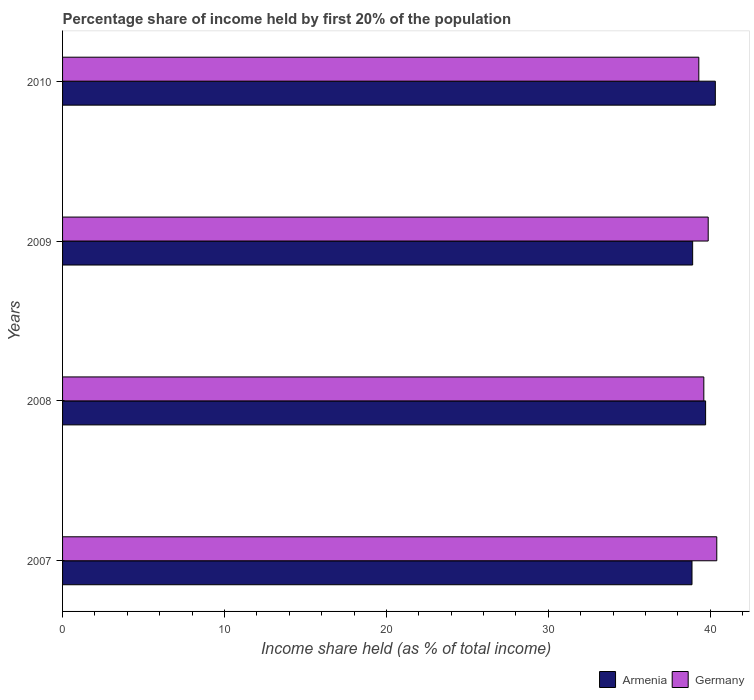How many different coloured bars are there?
Provide a short and direct response. 2. Are the number of bars per tick equal to the number of legend labels?
Ensure brevity in your answer.  Yes. How many bars are there on the 1st tick from the bottom?
Make the answer very short. 2. What is the label of the 3rd group of bars from the top?
Your response must be concise. 2008. In how many cases, is the number of bars for a given year not equal to the number of legend labels?
Make the answer very short. 0. What is the share of income held by first 20% of the population in Armenia in 2007?
Your response must be concise. 38.87. Across all years, what is the maximum share of income held by first 20% of the population in Armenia?
Offer a terse response. 40.31. Across all years, what is the minimum share of income held by first 20% of the population in Germany?
Give a very brief answer. 39.29. In which year was the share of income held by first 20% of the population in Armenia maximum?
Make the answer very short. 2010. In which year was the share of income held by first 20% of the population in Armenia minimum?
Make the answer very short. 2007. What is the total share of income held by first 20% of the population in Germany in the graph?
Keep it short and to the point. 159.16. What is the difference between the share of income held by first 20% of the population in Armenia in 2007 and that in 2008?
Make the answer very short. -0.84. What is the difference between the share of income held by first 20% of the population in Germany in 2010 and the share of income held by first 20% of the population in Armenia in 2007?
Offer a very short reply. 0.42. What is the average share of income held by first 20% of the population in Armenia per year?
Your response must be concise. 39.45. In the year 2008, what is the difference between the share of income held by first 20% of the population in Germany and share of income held by first 20% of the population in Armenia?
Provide a short and direct response. -0.11. In how many years, is the share of income held by first 20% of the population in Germany greater than 8 %?
Ensure brevity in your answer.  4. What is the ratio of the share of income held by first 20% of the population in Germany in 2007 to that in 2009?
Keep it short and to the point. 1.01. Is the share of income held by first 20% of the population in Armenia in 2009 less than that in 2010?
Offer a very short reply. Yes. Is the difference between the share of income held by first 20% of the population in Germany in 2007 and 2008 greater than the difference between the share of income held by first 20% of the population in Armenia in 2007 and 2008?
Give a very brief answer. Yes. What is the difference between the highest and the second highest share of income held by first 20% of the population in Armenia?
Make the answer very short. 0.6. What is the difference between the highest and the lowest share of income held by first 20% of the population in Germany?
Ensure brevity in your answer.  1.11. What does the 2nd bar from the top in 2007 represents?
Your answer should be compact. Armenia. What does the 1st bar from the bottom in 2010 represents?
Provide a short and direct response. Armenia. How many bars are there?
Keep it short and to the point. 8. How many years are there in the graph?
Your answer should be compact. 4. Does the graph contain any zero values?
Give a very brief answer. No. Does the graph contain grids?
Give a very brief answer. No. How are the legend labels stacked?
Provide a succinct answer. Horizontal. What is the title of the graph?
Your answer should be compact. Percentage share of income held by first 20% of the population. What is the label or title of the X-axis?
Your answer should be very brief. Income share held (as % of total income). What is the label or title of the Y-axis?
Your answer should be very brief. Years. What is the Income share held (as % of total income) of Armenia in 2007?
Provide a short and direct response. 38.87. What is the Income share held (as % of total income) in Germany in 2007?
Your answer should be compact. 40.4. What is the Income share held (as % of total income) of Armenia in 2008?
Your response must be concise. 39.71. What is the Income share held (as % of total income) of Germany in 2008?
Your response must be concise. 39.6. What is the Income share held (as % of total income) of Armenia in 2009?
Your answer should be very brief. 38.91. What is the Income share held (as % of total income) of Germany in 2009?
Your response must be concise. 39.87. What is the Income share held (as % of total income) of Armenia in 2010?
Offer a very short reply. 40.31. What is the Income share held (as % of total income) in Germany in 2010?
Offer a very short reply. 39.29. Across all years, what is the maximum Income share held (as % of total income) in Armenia?
Your response must be concise. 40.31. Across all years, what is the maximum Income share held (as % of total income) of Germany?
Offer a terse response. 40.4. Across all years, what is the minimum Income share held (as % of total income) in Armenia?
Your response must be concise. 38.87. Across all years, what is the minimum Income share held (as % of total income) of Germany?
Your answer should be very brief. 39.29. What is the total Income share held (as % of total income) of Armenia in the graph?
Your response must be concise. 157.8. What is the total Income share held (as % of total income) in Germany in the graph?
Provide a short and direct response. 159.16. What is the difference between the Income share held (as % of total income) of Armenia in 2007 and that in 2008?
Your answer should be compact. -0.84. What is the difference between the Income share held (as % of total income) in Germany in 2007 and that in 2008?
Offer a very short reply. 0.8. What is the difference between the Income share held (as % of total income) of Armenia in 2007 and that in 2009?
Your answer should be compact. -0.04. What is the difference between the Income share held (as % of total income) of Germany in 2007 and that in 2009?
Give a very brief answer. 0.53. What is the difference between the Income share held (as % of total income) in Armenia in 2007 and that in 2010?
Keep it short and to the point. -1.44. What is the difference between the Income share held (as % of total income) in Germany in 2007 and that in 2010?
Ensure brevity in your answer.  1.11. What is the difference between the Income share held (as % of total income) of Germany in 2008 and that in 2009?
Provide a short and direct response. -0.27. What is the difference between the Income share held (as % of total income) in Germany in 2008 and that in 2010?
Provide a succinct answer. 0.31. What is the difference between the Income share held (as % of total income) in Armenia in 2009 and that in 2010?
Provide a succinct answer. -1.4. What is the difference between the Income share held (as % of total income) in Germany in 2009 and that in 2010?
Your answer should be very brief. 0.58. What is the difference between the Income share held (as % of total income) of Armenia in 2007 and the Income share held (as % of total income) of Germany in 2008?
Your answer should be compact. -0.73. What is the difference between the Income share held (as % of total income) of Armenia in 2007 and the Income share held (as % of total income) of Germany in 2009?
Your answer should be compact. -1. What is the difference between the Income share held (as % of total income) in Armenia in 2007 and the Income share held (as % of total income) in Germany in 2010?
Provide a short and direct response. -0.42. What is the difference between the Income share held (as % of total income) of Armenia in 2008 and the Income share held (as % of total income) of Germany in 2009?
Keep it short and to the point. -0.16. What is the difference between the Income share held (as % of total income) in Armenia in 2008 and the Income share held (as % of total income) in Germany in 2010?
Keep it short and to the point. 0.42. What is the difference between the Income share held (as % of total income) of Armenia in 2009 and the Income share held (as % of total income) of Germany in 2010?
Offer a very short reply. -0.38. What is the average Income share held (as % of total income) in Armenia per year?
Keep it short and to the point. 39.45. What is the average Income share held (as % of total income) of Germany per year?
Offer a terse response. 39.79. In the year 2007, what is the difference between the Income share held (as % of total income) of Armenia and Income share held (as % of total income) of Germany?
Ensure brevity in your answer.  -1.53. In the year 2008, what is the difference between the Income share held (as % of total income) of Armenia and Income share held (as % of total income) of Germany?
Provide a short and direct response. 0.11. In the year 2009, what is the difference between the Income share held (as % of total income) in Armenia and Income share held (as % of total income) in Germany?
Offer a terse response. -0.96. In the year 2010, what is the difference between the Income share held (as % of total income) of Armenia and Income share held (as % of total income) of Germany?
Offer a terse response. 1.02. What is the ratio of the Income share held (as % of total income) in Armenia in 2007 to that in 2008?
Make the answer very short. 0.98. What is the ratio of the Income share held (as % of total income) of Germany in 2007 to that in 2008?
Offer a terse response. 1.02. What is the ratio of the Income share held (as % of total income) of Armenia in 2007 to that in 2009?
Offer a very short reply. 1. What is the ratio of the Income share held (as % of total income) of Germany in 2007 to that in 2009?
Your answer should be very brief. 1.01. What is the ratio of the Income share held (as % of total income) of Armenia in 2007 to that in 2010?
Offer a terse response. 0.96. What is the ratio of the Income share held (as % of total income) of Germany in 2007 to that in 2010?
Provide a short and direct response. 1.03. What is the ratio of the Income share held (as % of total income) in Armenia in 2008 to that in 2009?
Ensure brevity in your answer.  1.02. What is the ratio of the Income share held (as % of total income) of Armenia in 2008 to that in 2010?
Keep it short and to the point. 0.99. What is the ratio of the Income share held (as % of total income) in Germany in 2008 to that in 2010?
Your response must be concise. 1.01. What is the ratio of the Income share held (as % of total income) in Armenia in 2009 to that in 2010?
Your answer should be very brief. 0.97. What is the ratio of the Income share held (as % of total income) in Germany in 2009 to that in 2010?
Offer a very short reply. 1.01. What is the difference between the highest and the second highest Income share held (as % of total income) in Armenia?
Keep it short and to the point. 0.6. What is the difference between the highest and the second highest Income share held (as % of total income) in Germany?
Your response must be concise. 0.53. What is the difference between the highest and the lowest Income share held (as % of total income) in Armenia?
Ensure brevity in your answer.  1.44. What is the difference between the highest and the lowest Income share held (as % of total income) of Germany?
Your answer should be very brief. 1.11. 